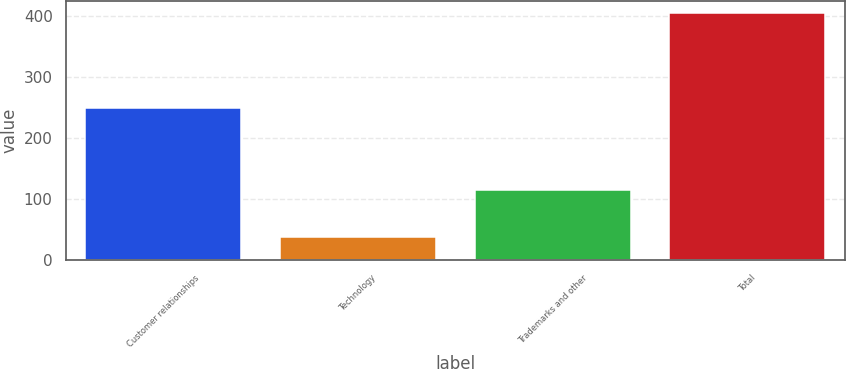<chart> <loc_0><loc_0><loc_500><loc_500><bar_chart><fcel>Customer relationships<fcel>Technology<fcel>Trademarks and other<fcel>Total<nl><fcel>250<fcel>39<fcel>116<fcel>405<nl></chart> 